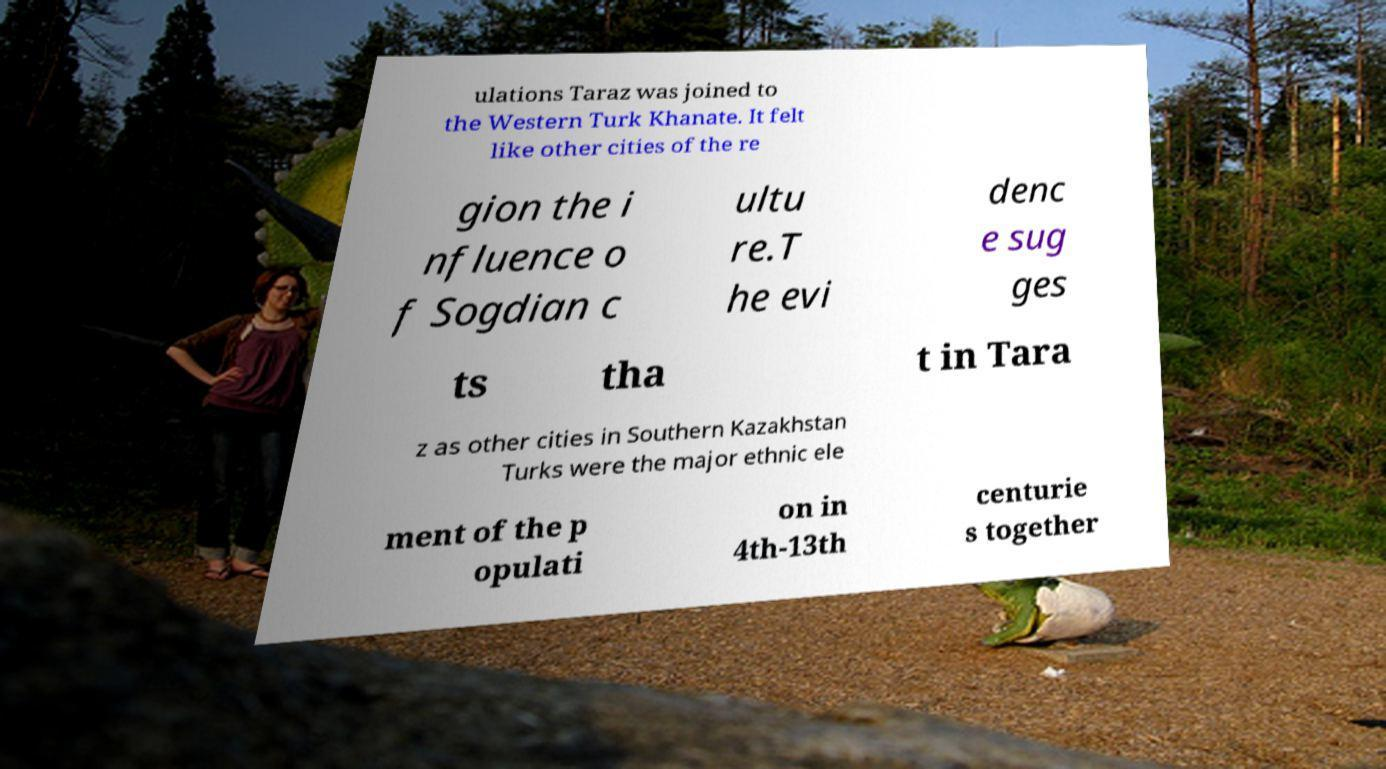Please read and relay the text visible in this image. What does it say? ulations Taraz was joined to the Western Turk Khanate. It felt like other cities of the re gion the i nfluence o f Sogdian c ultu re.T he evi denc e sug ges ts tha t in Tara z as other cities in Southern Kazakhstan Turks were the major ethnic ele ment of the p opulati on in 4th-13th centurie s together 